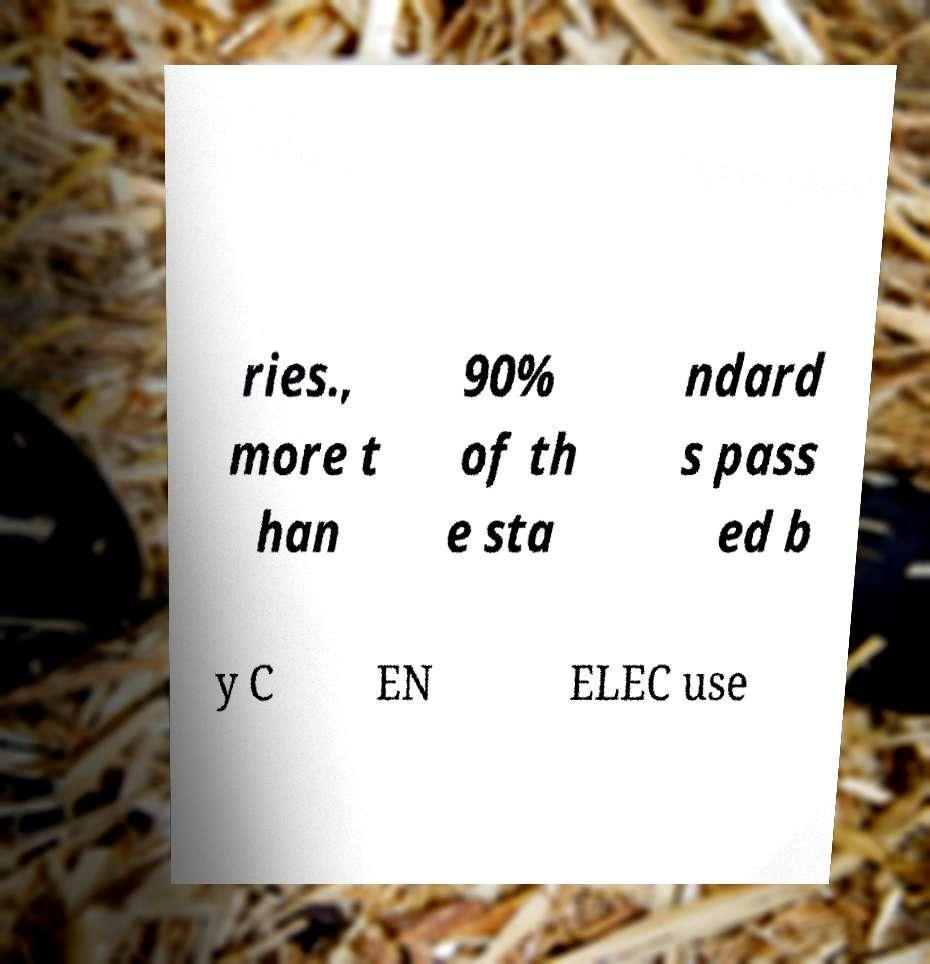I need the written content from this picture converted into text. Can you do that? ries., more t han 90% of th e sta ndard s pass ed b y C EN ELEC use 